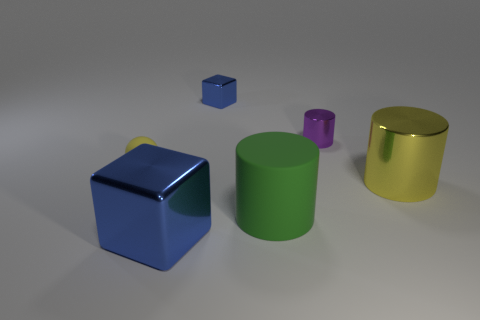Is the material of the yellow object that is right of the tiny block the same as the purple object?
Your response must be concise. Yes. How many objects are either large blocks or small things that are to the left of the small blue shiny thing?
Provide a short and direct response. 2. What color is the large block that is made of the same material as the tiny cube?
Your response must be concise. Blue. What number of tiny blue blocks are made of the same material as the small purple cylinder?
Provide a succinct answer. 1. How many small things are there?
Provide a succinct answer. 3. Does the metallic cylinder that is in front of the yellow matte sphere have the same color as the shiny block behind the tiny yellow sphere?
Provide a succinct answer. No. There is a yellow shiny cylinder; what number of shiny cylinders are behind it?
Ensure brevity in your answer.  1. There is a small cube that is the same color as the big metal cube; what is it made of?
Provide a short and direct response. Metal. Are there any small gray shiny things of the same shape as the small purple metal thing?
Give a very brief answer. No. Do the blue block that is in front of the sphere and the yellow thing on the left side of the small blue shiny object have the same material?
Offer a terse response. No. 